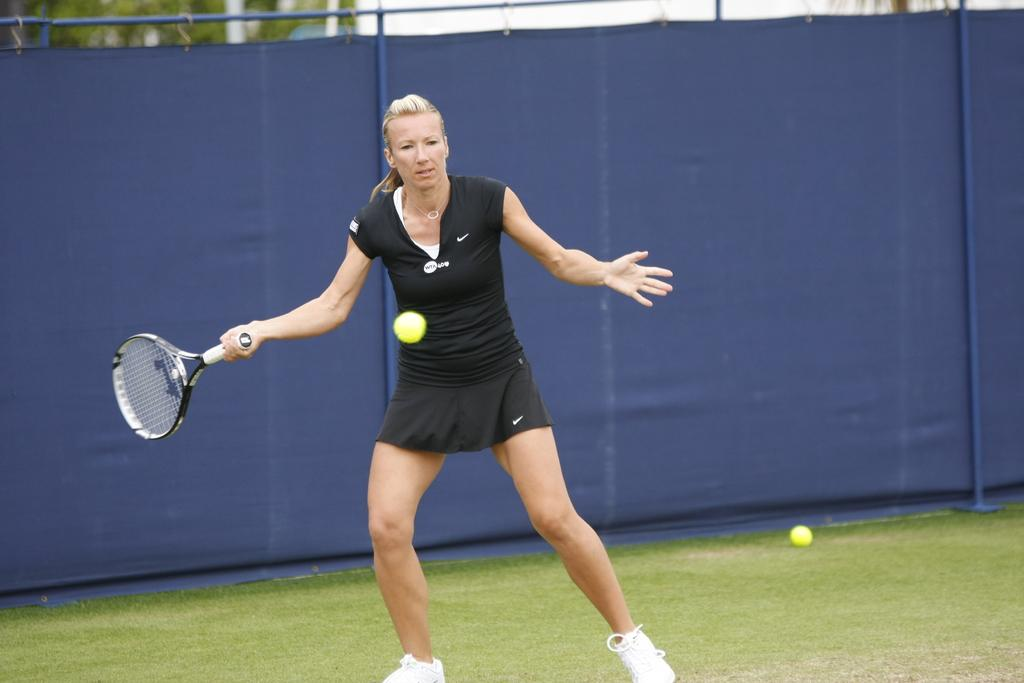Who is present in the image? There is a woman in the image. What is the woman doing in the image? The woman is standing and holding a bat in her hand. What can be seen in the background of the image? There is a blue color cloth in the background. Where might this image have been taken? The image appears to be set in a playing ground. What type of duck can be seen swimming in the pond in the image? There is no duck or pond present in the image; it features a woman holding a bat in a playing ground setting. 